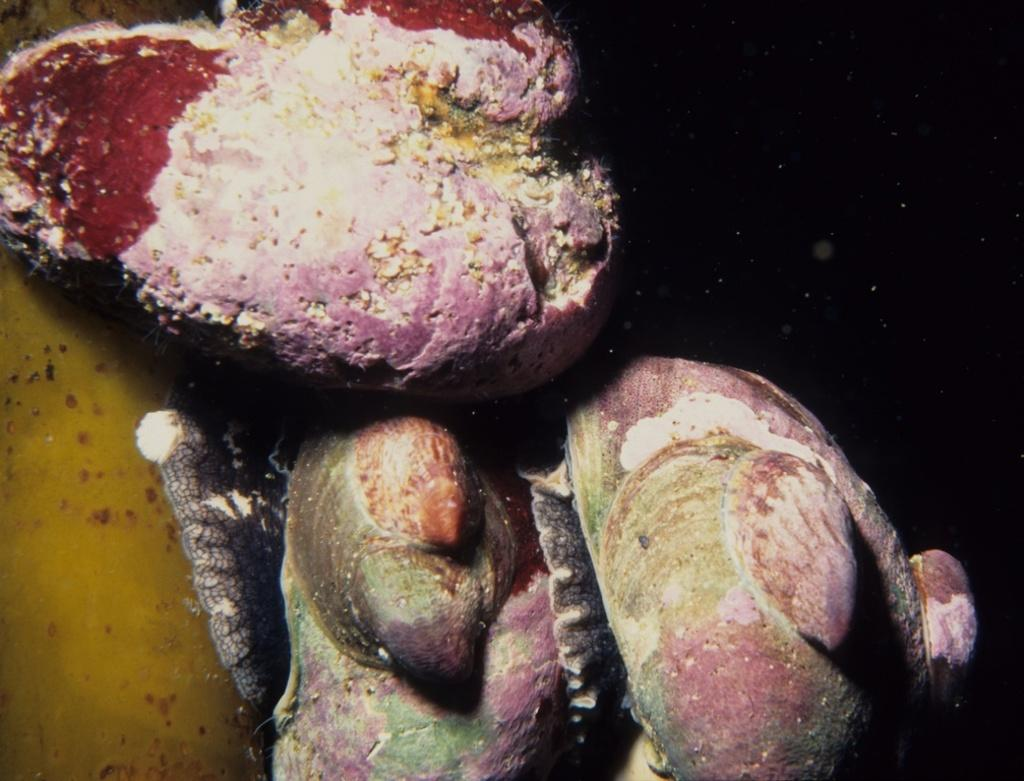What type of underwater environment is depicted in the image? There is a coral reef in the image. Can you describe the colors and textures of the coral reef? The coral reef features various colors and textures, including vibrant hues and intricate patterns. What type of marine life might be found in a coral reef environment? Coral reefs are home to a diverse array of marine life, including fish, sea turtles, and various invertebrates. How does the coral reef pull the steam from the water in the image? There is no steam present in the image, and coral reefs do not have the ability to pull steam from water. 